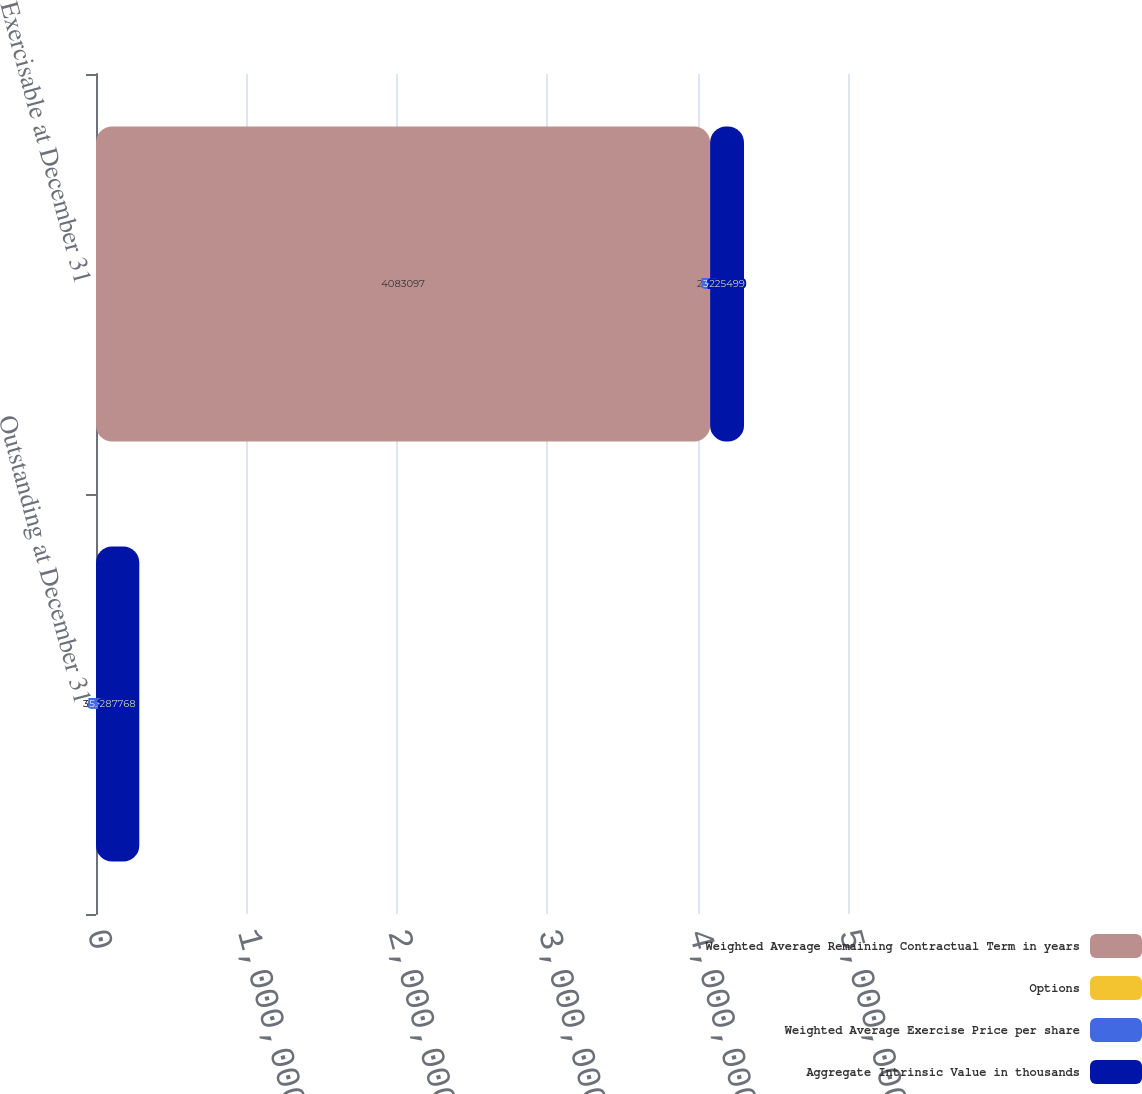Convert chart. <chart><loc_0><loc_0><loc_500><loc_500><stacked_bar_chart><ecel><fcel>Outstanding at December 31<fcel>Exercisable at December 31<nl><fcel>Weighted Average Remaining Contractual Term in years<fcel>32.98<fcel>4.0831e+06<nl><fcel>Options<fcel>32.98<fcel>24.29<nl><fcel>Weighted Average Exercise Price per share<fcel>5.5<fcel>3.8<nl><fcel>Aggregate Intrinsic Value in thousands<fcel>287768<fcel>225499<nl></chart> 